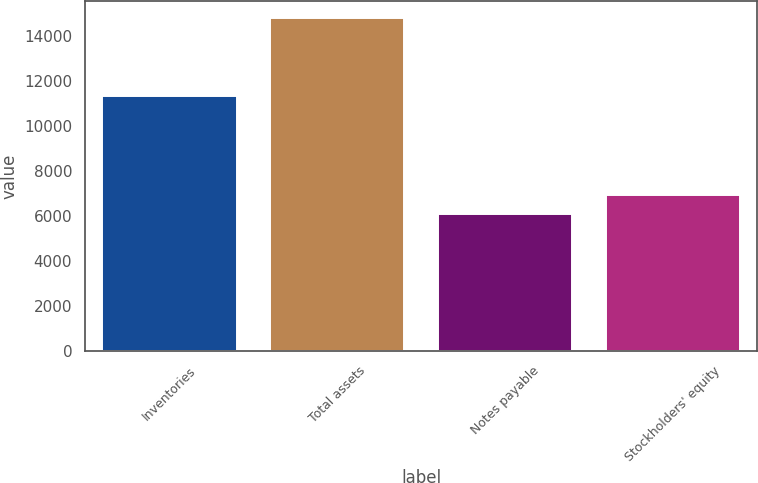Convert chart to OTSL. <chart><loc_0><loc_0><loc_500><loc_500><bar_chart><fcel>Inventories<fcel>Total assets<fcel>Notes payable<fcel>Stockholders' equity<nl><fcel>11343.1<fcel>14820.7<fcel>6078.6<fcel>6952.81<nl></chart> 